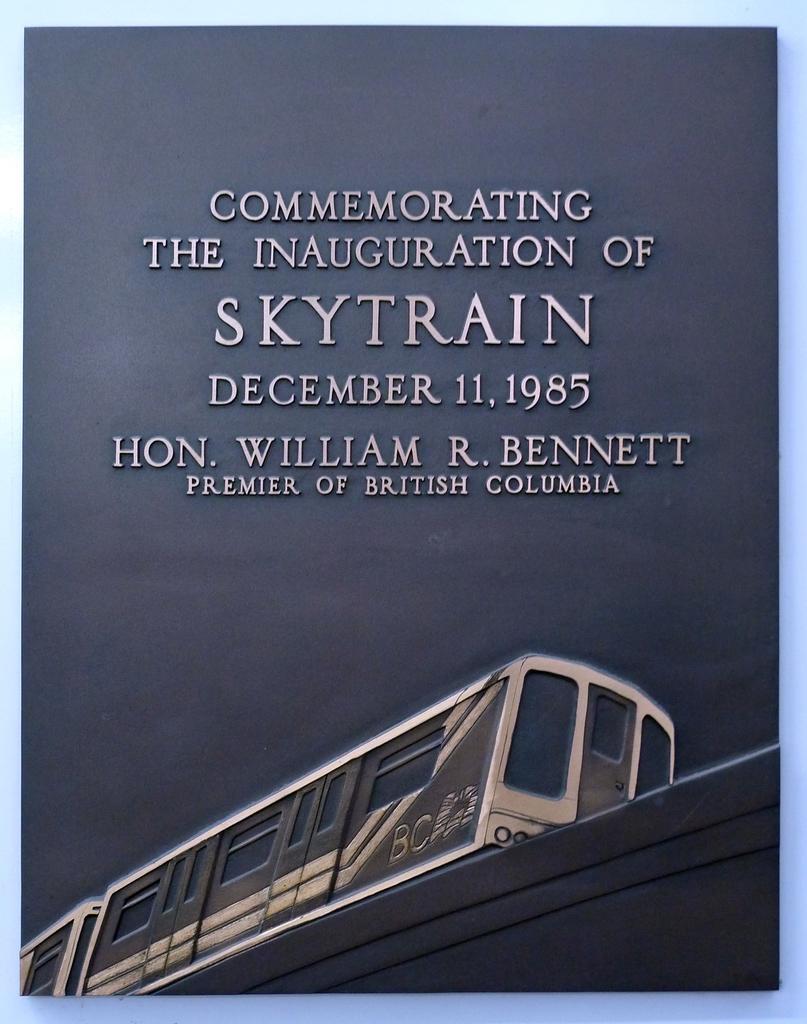Please provide a concise description of this image. It looks like an image on the book, at the bottom there is the train. 